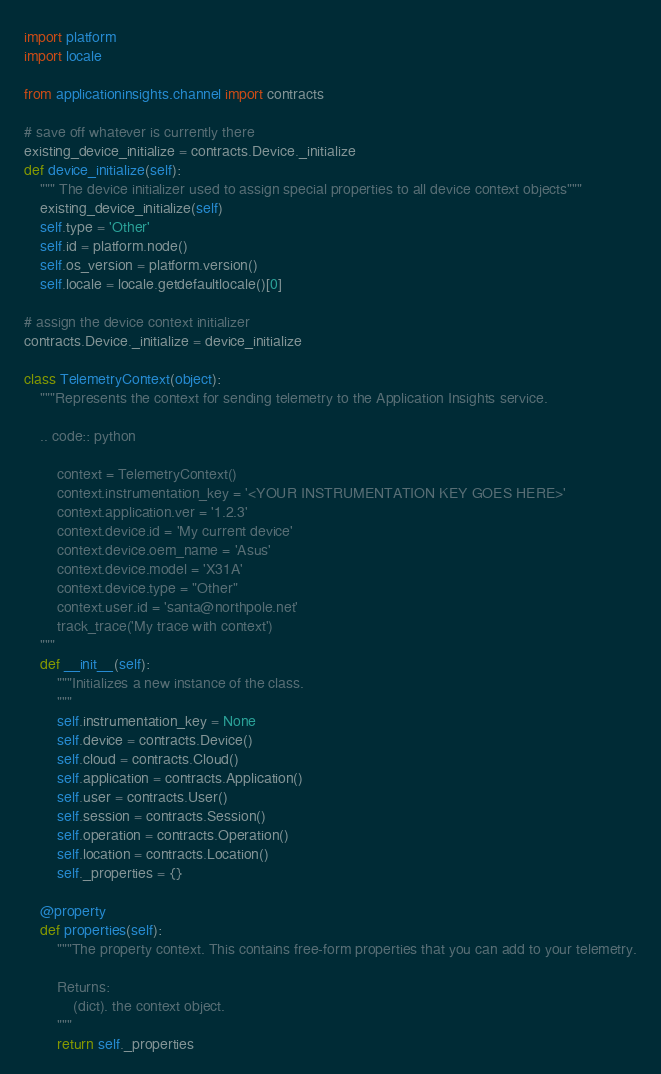Convert code to text. <code><loc_0><loc_0><loc_500><loc_500><_Python_>import platform
import locale

from applicationinsights.channel import contracts

# save off whatever is currently there
existing_device_initialize = contracts.Device._initialize
def device_initialize(self):
    """ The device initializer used to assign special properties to all device context objects"""
    existing_device_initialize(self)
    self.type = 'Other'
    self.id = platform.node()
    self.os_version = platform.version()
    self.locale = locale.getdefaultlocale()[0]

# assign the device context initializer
contracts.Device._initialize = device_initialize

class TelemetryContext(object):
    """Represents the context for sending telemetry to the Application Insights service.

    .. code:: python

        context = TelemetryContext()
        context.instrumentation_key = '<YOUR INSTRUMENTATION KEY GOES HERE>'
        context.application.ver = '1.2.3'
        context.device.id = 'My current device'
        context.device.oem_name = 'Asus'
        context.device.model = 'X31A'
        context.device.type = "Other"
        context.user.id = 'santa@northpole.net'
        track_trace('My trace with context')
    """
    def __init__(self):
        """Initializes a new instance of the class.
        """
        self.instrumentation_key = None
        self.device = contracts.Device()
        self.cloud = contracts.Cloud()
        self.application = contracts.Application()
        self.user = contracts.User()
        self.session = contracts.Session()
        self.operation = contracts.Operation()
        self.location = contracts.Location()
        self._properties = {}

    @property
    def properties(self):
        """The property context. This contains free-form properties that you can add to your telemetry.

        Returns:
            (dict). the context object.
        """
        return self._properties
</code> 